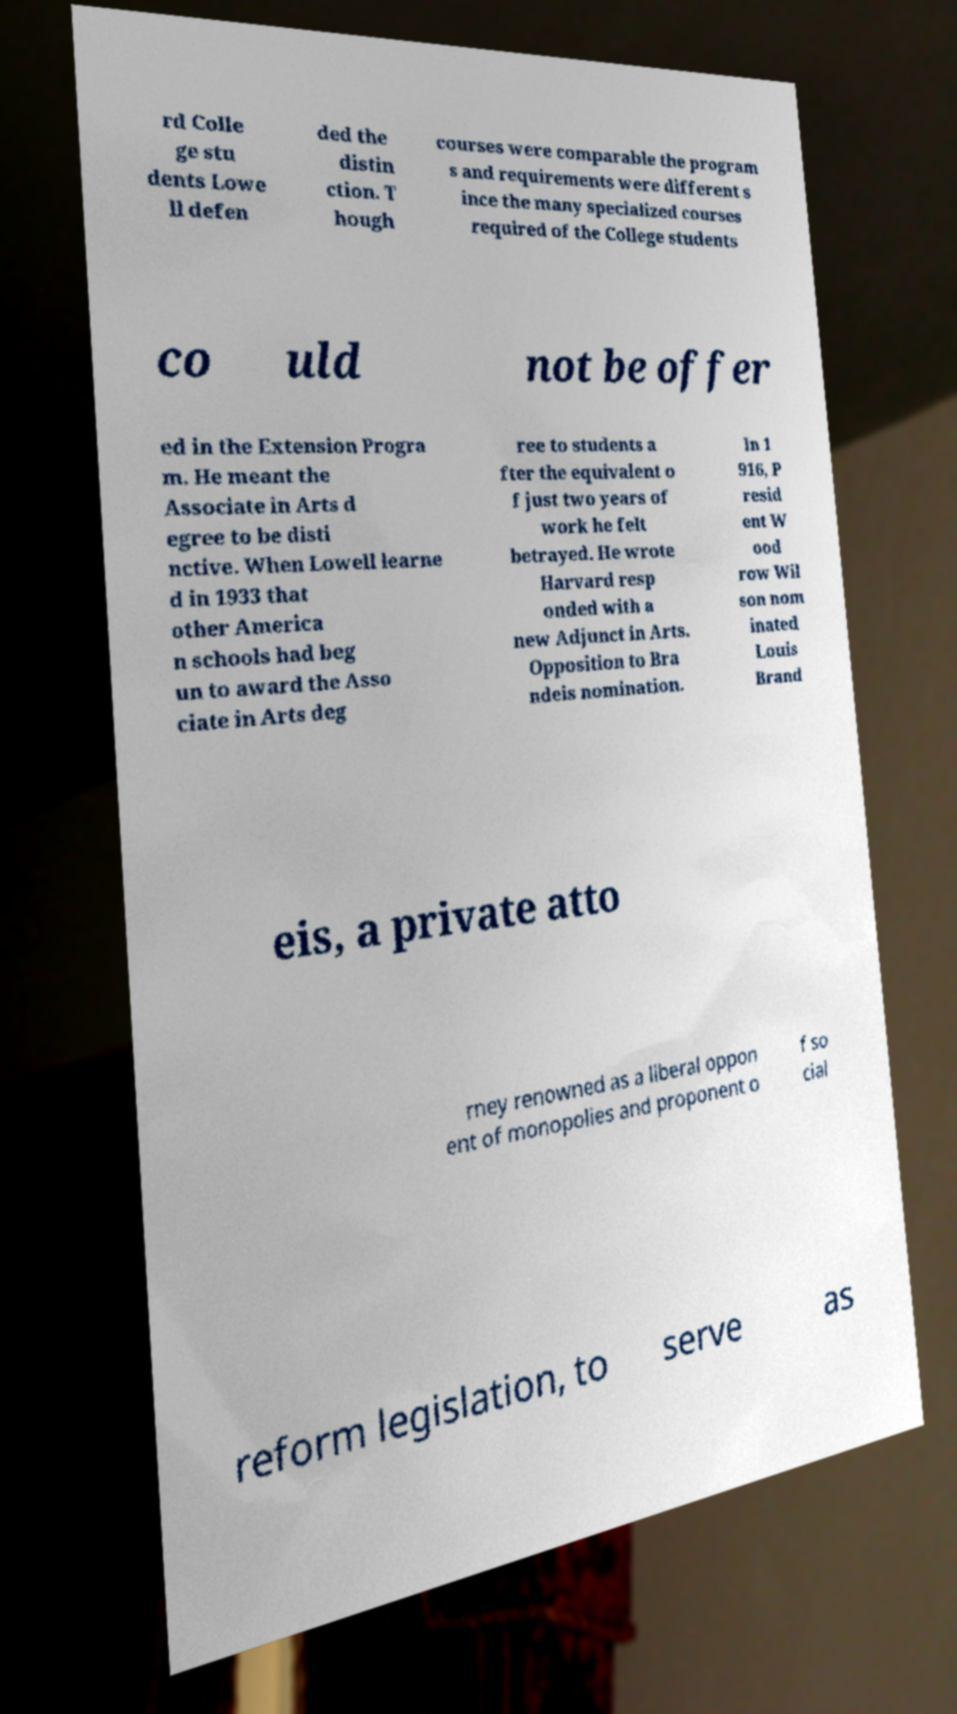Can you accurately transcribe the text from the provided image for me? rd Colle ge stu dents Lowe ll defen ded the distin ction. T hough courses were comparable the program s and requirements were different s ince the many specialized courses required of the College students co uld not be offer ed in the Extension Progra m. He meant the Associate in Arts d egree to be disti nctive. When Lowell learne d in 1933 that other America n schools had beg un to award the Asso ciate in Arts deg ree to students a fter the equivalent o f just two years of work he felt betrayed. He wrote Harvard resp onded with a new Adjunct in Arts. Opposition to Bra ndeis nomination. In 1 916, P resid ent W ood row Wil son nom inated Louis Brand eis, a private atto rney renowned as a liberal oppon ent of monopolies and proponent o f so cial reform legislation, to serve as 